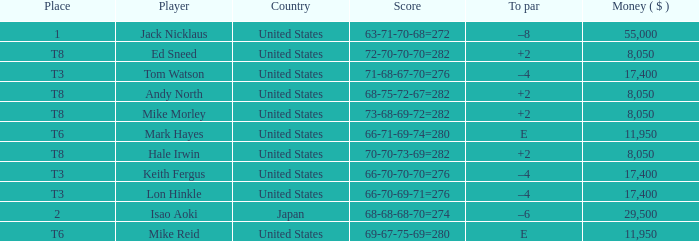What player has money larger than 11,950 and is placed in t8 and has the score of 73-68-69-72=282? None. 